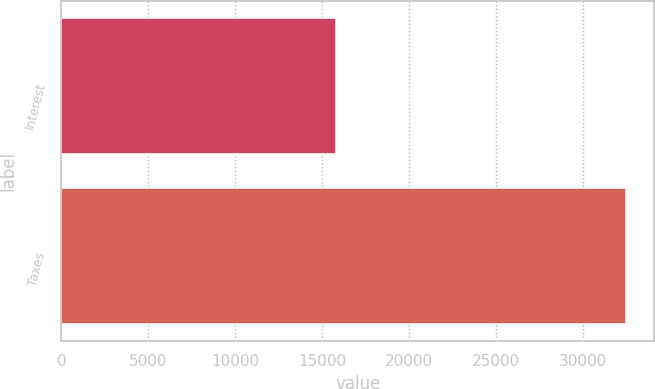Convert chart. <chart><loc_0><loc_0><loc_500><loc_500><bar_chart><fcel>Interest<fcel>Taxes<nl><fcel>15815<fcel>32465<nl></chart> 